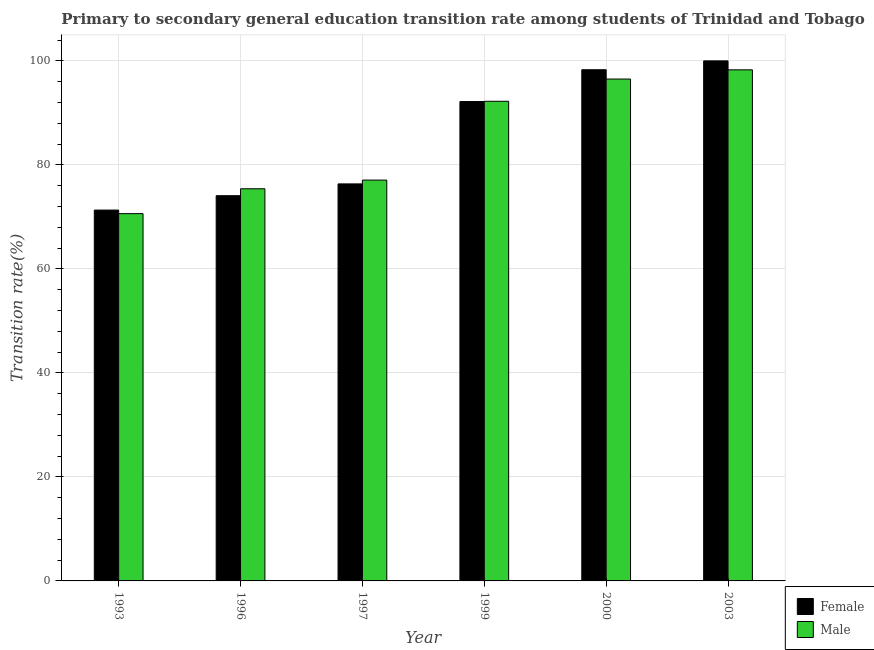How many bars are there on the 1st tick from the right?
Make the answer very short. 2. What is the label of the 4th group of bars from the left?
Your answer should be compact. 1999. In how many cases, is the number of bars for a given year not equal to the number of legend labels?
Make the answer very short. 0. Across all years, what is the maximum transition rate among female students?
Your response must be concise. 100. Across all years, what is the minimum transition rate among female students?
Ensure brevity in your answer.  71.31. In which year was the transition rate among female students minimum?
Provide a succinct answer. 1993. What is the total transition rate among female students in the graph?
Give a very brief answer. 512.21. What is the difference between the transition rate among female students in 1993 and that in 1997?
Ensure brevity in your answer.  -5.03. What is the difference between the transition rate among female students in 1997 and the transition rate among male students in 1999?
Provide a succinct answer. -15.84. What is the average transition rate among male students per year?
Offer a very short reply. 85.02. In the year 1993, what is the difference between the transition rate among female students and transition rate among male students?
Your response must be concise. 0. What is the ratio of the transition rate among male students in 1997 to that in 2003?
Your answer should be very brief. 0.78. Is the transition rate among male students in 1997 less than that in 1999?
Give a very brief answer. Yes. What is the difference between the highest and the second highest transition rate among male students?
Keep it short and to the point. 1.77. What is the difference between the highest and the lowest transition rate among male students?
Offer a very short reply. 27.65. Is the sum of the transition rate among female students in 1996 and 2003 greater than the maximum transition rate among male students across all years?
Your answer should be very brief. Yes. What does the 1st bar from the left in 1993 represents?
Make the answer very short. Female. How many bars are there?
Give a very brief answer. 12. How many years are there in the graph?
Keep it short and to the point. 6. Are the values on the major ticks of Y-axis written in scientific E-notation?
Offer a terse response. No. Does the graph contain any zero values?
Give a very brief answer. No. Does the graph contain grids?
Your answer should be very brief. Yes. Where does the legend appear in the graph?
Make the answer very short. Bottom right. How many legend labels are there?
Offer a terse response. 2. What is the title of the graph?
Offer a very short reply. Primary to secondary general education transition rate among students of Trinidad and Tobago. Does "Non-solid fuel" appear as one of the legend labels in the graph?
Your response must be concise. No. What is the label or title of the Y-axis?
Make the answer very short. Transition rate(%). What is the Transition rate(%) in Female in 1993?
Offer a very short reply. 71.31. What is the Transition rate(%) in Male in 1993?
Offer a terse response. 70.63. What is the Transition rate(%) in Female in 1996?
Offer a terse response. 74.08. What is the Transition rate(%) of Male in 1996?
Offer a terse response. 75.41. What is the Transition rate(%) of Female in 1997?
Offer a very short reply. 76.34. What is the Transition rate(%) in Male in 1997?
Provide a short and direct response. 77.08. What is the Transition rate(%) in Female in 1999?
Ensure brevity in your answer.  92.18. What is the Transition rate(%) of Male in 1999?
Your answer should be very brief. 92.23. What is the Transition rate(%) of Female in 2000?
Your response must be concise. 98.3. What is the Transition rate(%) of Male in 2000?
Offer a terse response. 96.51. What is the Transition rate(%) in Female in 2003?
Keep it short and to the point. 100. What is the Transition rate(%) of Male in 2003?
Offer a terse response. 98.28. Across all years, what is the maximum Transition rate(%) of Male?
Provide a succinct answer. 98.28. Across all years, what is the minimum Transition rate(%) of Female?
Ensure brevity in your answer.  71.31. Across all years, what is the minimum Transition rate(%) in Male?
Your answer should be compact. 70.63. What is the total Transition rate(%) in Female in the graph?
Provide a succinct answer. 512.21. What is the total Transition rate(%) in Male in the graph?
Ensure brevity in your answer.  510.13. What is the difference between the Transition rate(%) in Female in 1993 and that in 1996?
Your answer should be compact. -2.77. What is the difference between the Transition rate(%) in Male in 1993 and that in 1996?
Offer a terse response. -4.78. What is the difference between the Transition rate(%) of Female in 1993 and that in 1997?
Make the answer very short. -5.03. What is the difference between the Transition rate(%) in Male in 1993 and that in 1997?
Your response must be concise. -6.45. What is the difference between the Transition rate(%) in Female in 1993 and that in 1999?
Ensure brevity in your answer.  -20.87. What is the difference between the Transition rate(%) of Male in 1993 and that in 1999?
Offer a terse response. -21.6. What is the difference between the Transition rate(%) of Female in 1993 and that in 2000?
Offer a terse response. -26.99. What is the difference between the Transition rate(%) of Male in 1993 and that in 2000?
Ensure brevity in your answer.  -25.88. What is the difference between the Transition rate(%) of Female in 1993 and that in 2003?
Give a very brief answer. -28.69. What is the difference between the Transition rate(%) in Male in 1993 and that in 2003?
Keep it short and to the point. -27.65. What is the difference between the Transition rate(%) in Female in 1996 and that in 1997?
Provide a succinct answer. -2.27. What is the difference between the Transition rate(%) of Male in 1996 and that in 1997?
Provide a succinct answer. -1.67. What is the difference between the Transition rate(%) of Female in 1996 and that in 1999?
Your answer should be very brief. -18.1. What is the difference between the Transition rate(%) of Male in 1996 and that in 1999?
Your response must be concise. -16.82. What is the difference between the Transition rate(%) in Female in 1996 and that in 2000?
Offer a very short reply. -24.22. What is the difference between the Transition rate(%) in Male in 1996 and that in 2000?
Keep it short and to the point. -21.1. What is the difference between the Transition rate(%) in Female in 1996 and that in 2003?
Offer a very short reply. -25.92. What is the difference between the Transition rate(%) in Male in 1996 and that in 2003?
Offer a very short reply. -22.87. What is the difference between the Transition rate(%) in Female in 1997 and that in 1999?
Make the answer very short. -15.84. What is the difference between the Transition rate(%) of Male in 1997 and that in 1999?
Keep it short and to the point. -15.15. What is the difference between the Transition rate(%) in Female in 1997 and that in 2000?
Your answer should be very brief. -21.95. What is the difference between the Transition rate(%) in Male in 1997 and that in 2000?
Offer a very short reply. -19.43. What is the difference between the Transition rate(%) of Female in 1997 and that in 2003?
Ensure brevity in your answer.  -23.66. What is the difference between the Transition rate(%) in Male in 1997 and that in 2003?
Give a very brief answer. -21.2. What is the difference between the Transition rate(%) of Female in 1999 and that in 2000?
Provide a succinct answer. -6.12. What is the difference between the Transition rate(%) in Male in 1999 and that in 2000?
Your answer should be compact. -4.28. What is the difference between the Transition rate(%) of Female in 1999 and that in 2003?
Provide a short and direct response. -7.82. What is the difference between the Transition rate(%) in Male in 1999 and that in 2003?
Offer a very short reply. -6.05. What is the difference between the Transition rate(%) in Female in 2000 and that in 2003?
Your response must be concise. -1.7. What is the difference between the Transition rate(%) of Male in 2000 and that in 2003?
Your response must be concise. -1.77. What is the difference between the Transition rate(%) of Female in 1993 and the Transition rate(%) of Male in 1996?
Make the answer very short. -4.1. What is the difference between the Transition rate(%) in Female in 1993 and the Transition rate(%) in Male in 1997?
Your response must be concise. -5.77. What is the difference between the Transition rate(%) of Female in 1993 and the Transition rate(%) of Male in 1999?
Make the answer very short. -20.92. What is the difference between the Transition rate(%) in Female in 1993 and the Transition rate(%) in Male in 2000?
Ensure brevity in your answer.  -25.2. What is the difference between the Transition rate(%) of Female in 1993 and the Transition rate(%) of Male in 2003?
Your answer should be compact. -26.97. What is the difference between the Transition rate(%) of Female in 1996 and the Transition rate(%) of Male in 1997?
Offer a terse response. -3. What is the difference between the Transition rate(%) of Female in 1996 and the Transition rate(%) of Male in 1999?
Ensure brevity in your answer.  -18.15. What is the difference between the Transition rate(%) in Female in 1996 and the Transition rate(%) in Male in 2000?
Make the answer very short. -22.43. What is the difference between the Transition rate(%) in Female in 1996 and the Transition rate(%) in Male in 2003?
Make the answer very short. -24.2. What is the difference between the Transition rate(%) of Female in 1997 and the Transition rate(%) of Male in 1999?
Keep it short and to the point. -15.89. What is the difference between the Transition rate(%) in Female in 1997 and the Transition rate(%) in Male in 2000?
Provide a short and direct response. -20.16. What is the difference between the Transition rate(%) of Female in 1997 and the Transition rate(%) of Male in 2003?
Provide a succinct answer. -21.93. What is the difference between the Transition rate(%) in Female in 1999 and the Transition rate(%) in Male in 2000?
Your answer should be very brief. -4.33. What is the difference between the Transition rate(%) in Female in 1999 and the Transition rate(%) in Male in 2003?
Offer a very short reply. -6.1. What is the difference between the Transition rate(%) of Female in 2000 and the Transition rate(%) of Male in 2003?
Offer a very short reply. 0.02. What is the average Transition rate(%) of Female per year?
Offer a terse response. 85.37. What is the average Transition rate(%) of Male per year?
Your answer should be very brief. 85.02. In the year 1993, what is the difference between the Transition rate(%) of Female and Transition rate(%) of Male?
Provide a succinct answer. 0.68. In the year 1996, what is the difference between the Transition rate(%) of Female and Transition rate(%) of Male?
Your answer should be very brief. -1.33. In the year 1997, what is the difference between the Transition rate(%) in Female and Transition rate(%) in Male?
Keep it short and to the point. -0.73. In the year 1999, what is the difference between the Transition rate(%) of Female and Transition rate(%) of Male?
Provide a succinct answer. -0.05. In the year 2000, what is the difference between the Transition rate(%) of Female and Transition rate(%) of Male?
Your answer should be very brief. 1.79. In the year 2003, what is the difference between the Transition rate(%) in Female and Transition rate(%) in Male?
Offer a terse response. 1.72. What is the ratio of the Transition rate(%) of Female in 1993 to that in 1996?
Offer a terse response. 0.96. What is the ratio of the Transition rate(%) of Male in 1993 to that in 1996?
Give a very brief answer. 0.94. What is the ratio of the Transition rate(%) in Female in 1993 to that in 1997?
Offer a terse response. 0.93. What is the ratio of the Transition rate(%) in Male in 1993 to that in 1997?
Keep it short and to the point. 0.92. What is the ratio of the Transition rate(%) of Female in 1993 to that in 1999?
Your response must be concise. 0.77. What is the ratio of the Transition rate(%) of Male in 1993 to that in 1999?
Offer a very short reply. 0.77. What is the ratio of the Transition rate(%) in Female in 1993 to that in 2000?
Make the answer very short. 0.73. What is the ratio of the Transition rate(%) of Male in 1993 to that in 2000?
Your response must be concise. 0.73. What is the ratio of the Transition rate(%) in Female in 1993 to that in 2003?
Give a very brief answer. 0.71. What is the ratio of the Transition rate(%) in Male in 1993 to that in 2003?
Offer a very short reply. 0.72. What is the ratio of the Transition rate(%) of Female in 1996 to that in 1997?
Provide a succinct answer. 0.97. What is the ratio of the Transition rate(%) in Male in 1996 to that in 1997?
Provide a succinct answer. 0.98. What is the ratio of the Transition rate(%) of Female in 1996 to that in 1999?
Offer a very short reply. 0.8. What is the ratio of the Transition rate(%) in Male in 1996 to that in 1999?
Your response must be concise. 0.82. What is the ratio of the Transition rate(%) in Female in 1996 to that in 2000?
Ensure brevity in your answer.  0.75. What is the ratio of the Transition rate(%) of Male in 1996 to that in 2000?
Your answer should be compact. 0.78. What is the ratio of the Transition rate(%) of Female in 1996 to that in 2003?
Your answer should be compact. 0.74. What is the ratio of the Transition rate(%) in Male in 1996 to that in 2003?
Your answer should be compact. 0.77. What is the ratio of the Transition rate(%) of Female in 1997 to that in 1999?
Your response must be concise. 0.83. What is the ratio of the Transition rate(%) in Male in 1997 to that in 1999?
Your response must be concise. 0.84. What is the ratio of the Transition rate(%) of Female in 1997 to that in 2000?
Your answer should be very brief. 0.78. What is the ratio of the Transition rate(%) in Male in 1997 to that in 2000?
Your response must be concise. 0.8. What is the ratio of the Transition rate(%) of Female in 1997 to that in 2003?
Offer a very short reply. 0.76. What is the ratio of the Transition rate(%) of Male in 1997 to that in 2003?
Offer a very short reply. 0.78. What is the ratio of the Transition rate(%) in Female in 1999 to that in 2000?
Provide a short and direct response. 0.94. What is the ratio of the Transition rate(%) in Male in 1999 to that in 2000?
Provide a succinct answer. 0.96. What is the ratio of the Transition rate(%) in Female in 1999 to that in 2003?
Provide a short and direct response. 0.92. What is the ratio of the Transition rate(%) of Male in 1999 to that in 2003?
Give a very brief answer. 0.94. What is the ratio of the Transition rate(%) in Female in 2000 to that in 2003?
Your answer should be very brief. 0.98. What is the difference between the highest and the second highest Transition rate(%) in Female?
Make the answer very short. 1.7. What is the difference between the highest and the second highest Transition rate(%) in Male?
Provide a succinct answer. 1.77. What is the difference between the highest and the lowest Transition rate(%) in Female?
Your response must be concise. 28.69. What is the difference between the highest and the lowest Transition rate(%) of Male?
Your answer should be very brief. 27.65. 